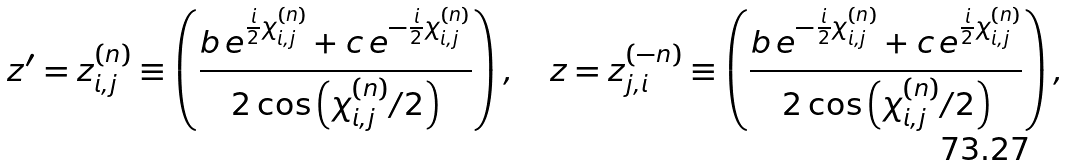<formula> <loc_0><loc_0><loc_500><loc_500>z ^ { \prime } = z ^ { ( n ) } _ { i , j } \equiv \left ( \frac { b \, e ^ { \frac { i } { 2 } \chi _ { i , j } ^ { ( n ) } } + c \, e ^ { - \frac { i } { 2 } \chi _ { i , j } ^ { ( n ) } } } { 2 \cos \left ( \chi _ { i , j } ^ { ( n ) } / 2 \right ) } \right ) , \quad z = z ^ { ( - n ) } _ { j , i } \equiv \left ( \frac { b \, e ^ { - \frac { i } { 2 } \chi _ { i , j } ^ { ( n ) } } + c \, e ^ { \frac { i } { 2 } \chi _ { i , j } ^ { ( n ) } } } { 2 \cos \left ( \chi _ { i , j } ^ { ( n ) } / 2 \right ) } \right ) ,</formula> 